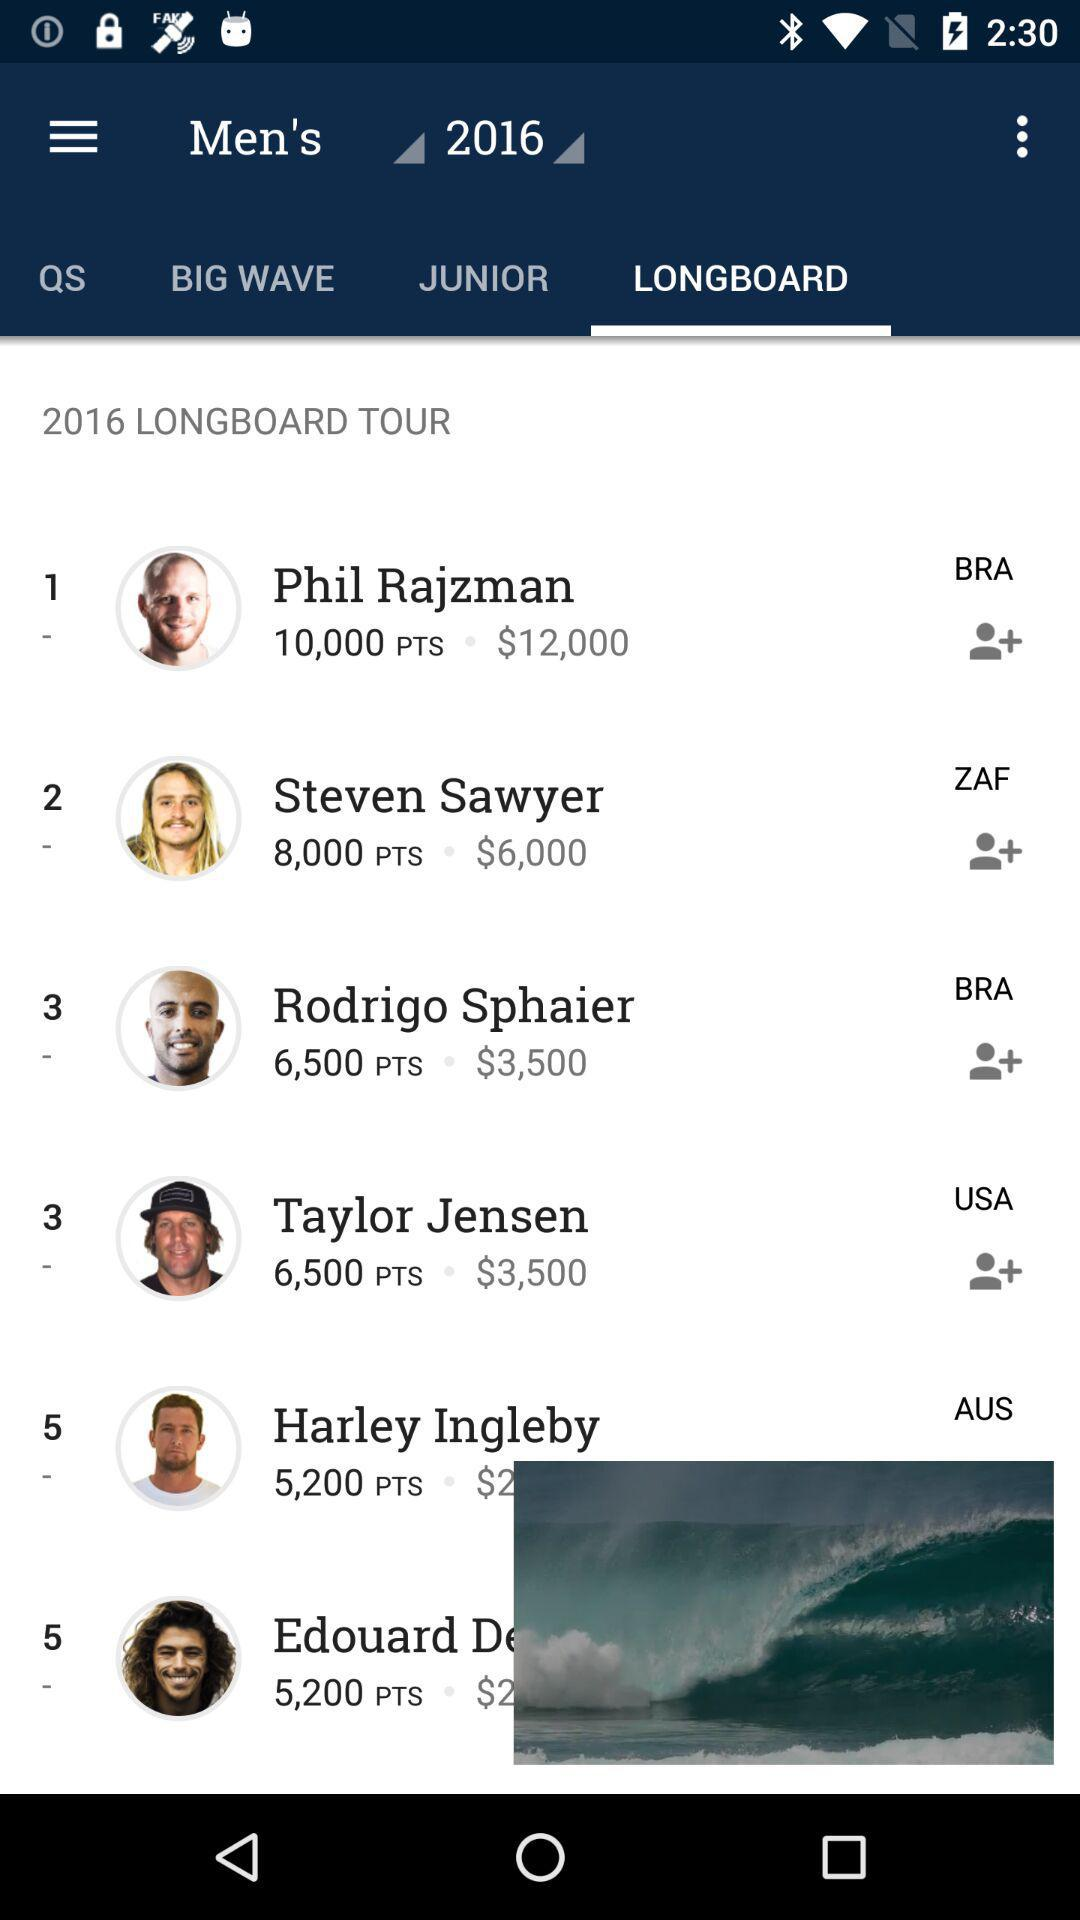What is the amount for Taylor Jensen? The amount is $3,500. 